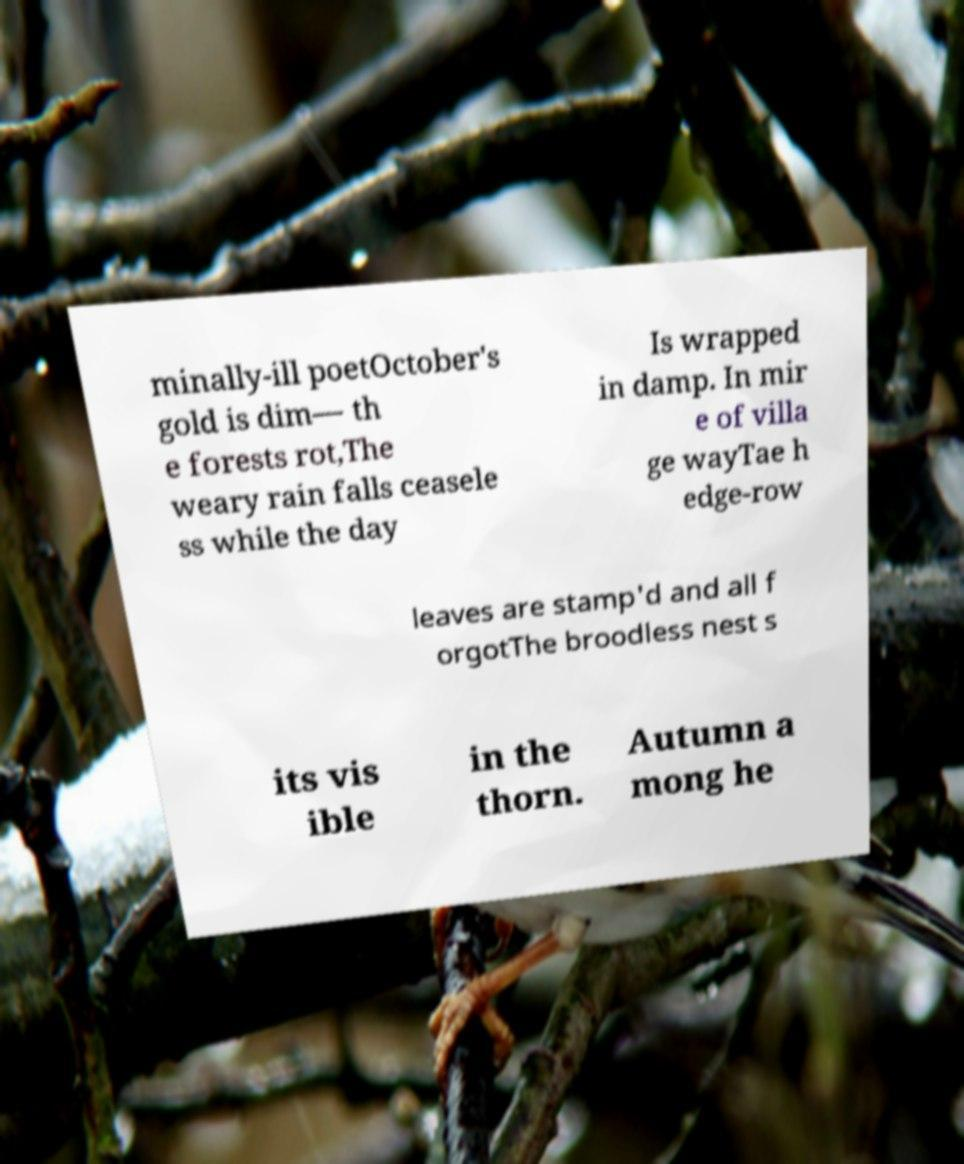Please read and relay the text visible in this image. What does it say? minally-ill poetOctober's gold is dim— th e forests rot,The weary rain falls ceasele ss while the day Is wrapped in damp. In mir e of villa ge wayTae h edge-row leaves are stamp'd and all f orgotThe broodless nest s its vis ible in the thorn. Autumn a mong he 